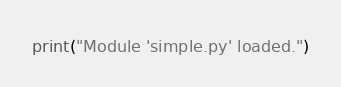<code> <loc_0><loc_0><loc_500><loc_500><_Python_>


print("Module 'simple.py' loaded.")
</code> 